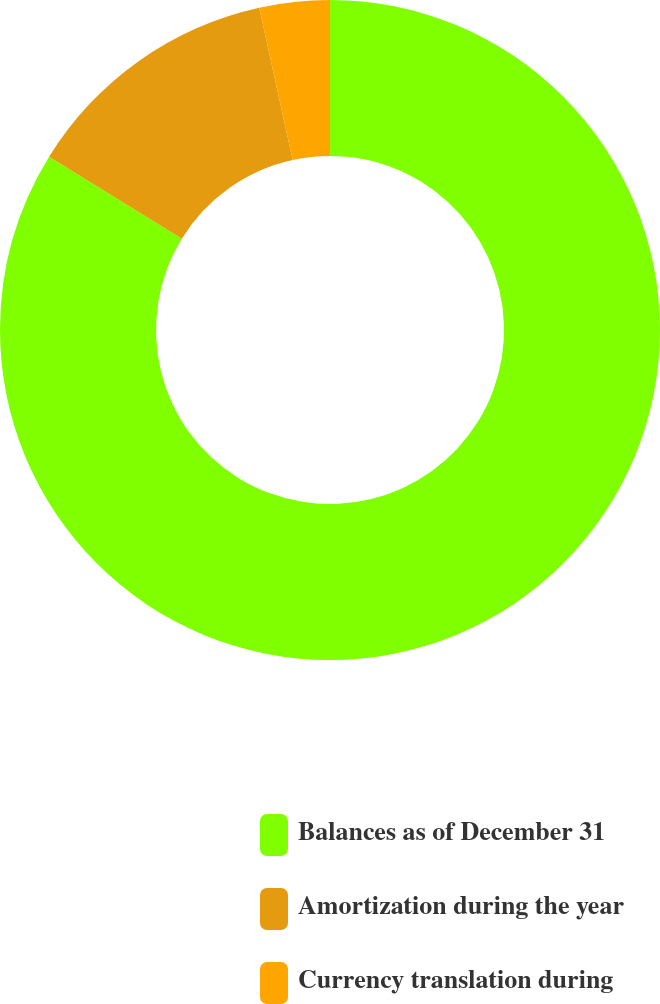Convert chart to OTSL. <chart><loc_0><loc_0><loc_500><loc_500><pie_chart><fcel>Balances as of December 31<fcel>Amortization during the year<fcel>Currency translation during<nl><fcel>83.79%<fcel>12.77%<fcel>3.44%<nl></chart> 